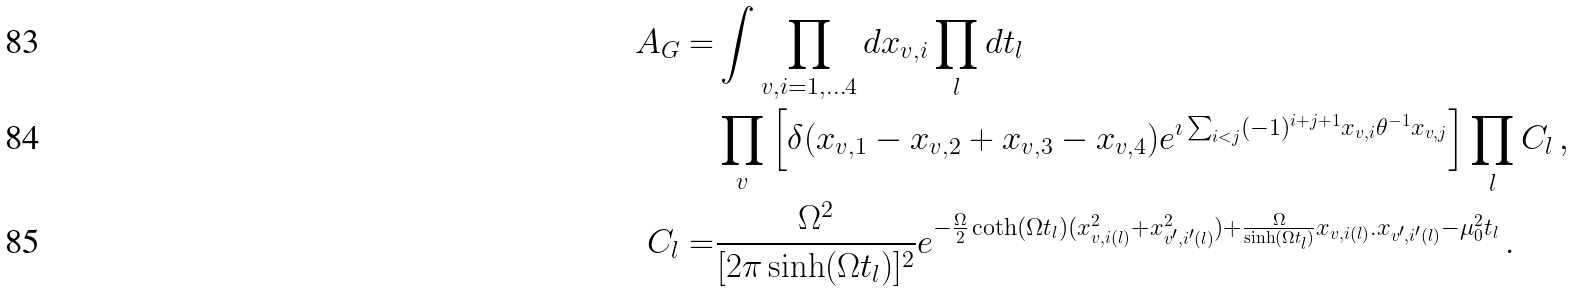Convert formula to latex. <formula><loc_0><loc_0><loc_500><loc_500>A _ { G } = & \int \prod _ { v , i = 1 , \dots 4 } d x _ { v , i } \prod _ { l } d t _ { l } \\ & \prod _ { v } \left [ \delta ( x _ { v , 1 } - x _ { v , 2 } + x _ { v , 3 } - x _ { v , 4 } ) e ^ { \imath \sum _ { i < j } ( - 1 ) ^ { i + j + 1 } x _ { v , i } \theta ^ { - 1 } x _ { v , j } } \right ] \prod _ { l } C _ { l } \, , \\ C _ { l } = & \frac { \Omega ^ { 2 } } { [ 2 \pi \sinh ( \Omega t _ { l } ) ] ^ { 2 } } e ^ { - \frac { \Omega } { 2 } \coth ( \Omega t _ { l } ) ( x _ { v , i ( l ) } ^ { 2 } + x _ { v ^ { \prime } , i ^ { \prime } ( l ) } ^ { 2 } ) + \frac { \Omega } { \sinh ( \Omega t _ { l } ) } x _ { v , i ( l ) } . x _ { v ^ { \prime } , i ^ { \prime } ( l ) } - \mu _ { 0 } ^ { 2 } t _ { l } } \, .</formula> 